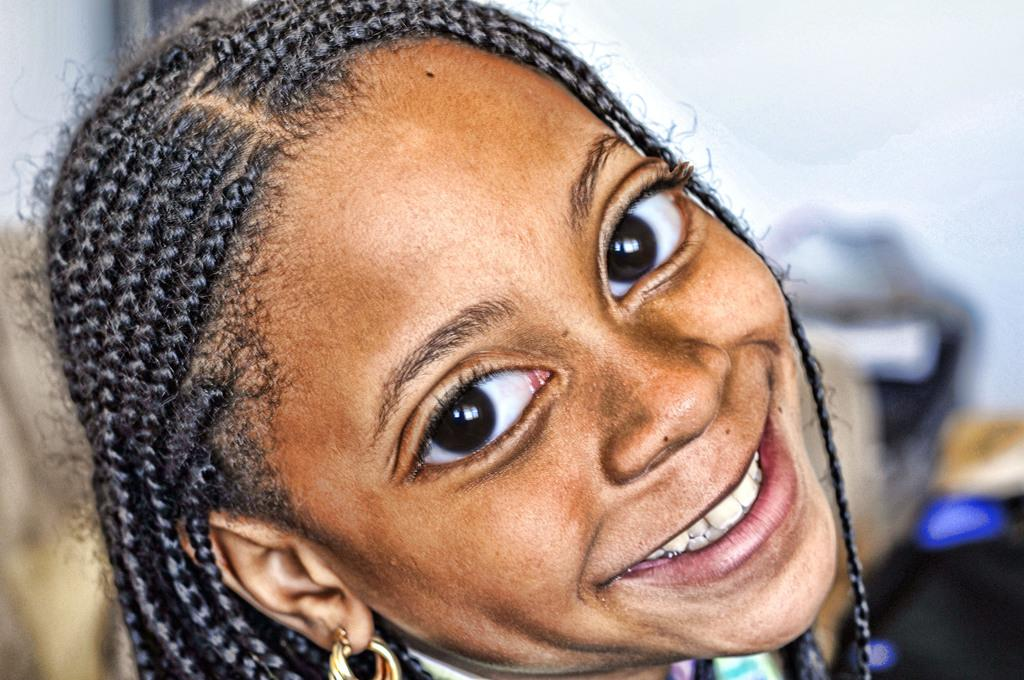What is the main subject of the image? There is a person's face in the image. Can you describe the background of the image? The background of the image is blurred. What type of prison can be seen in the background of the image? There is no prison present in the image; the background is blurred. How does the boat affect the person's face in the image? There is no boat present in the image, so it cannot affect the person's face. 